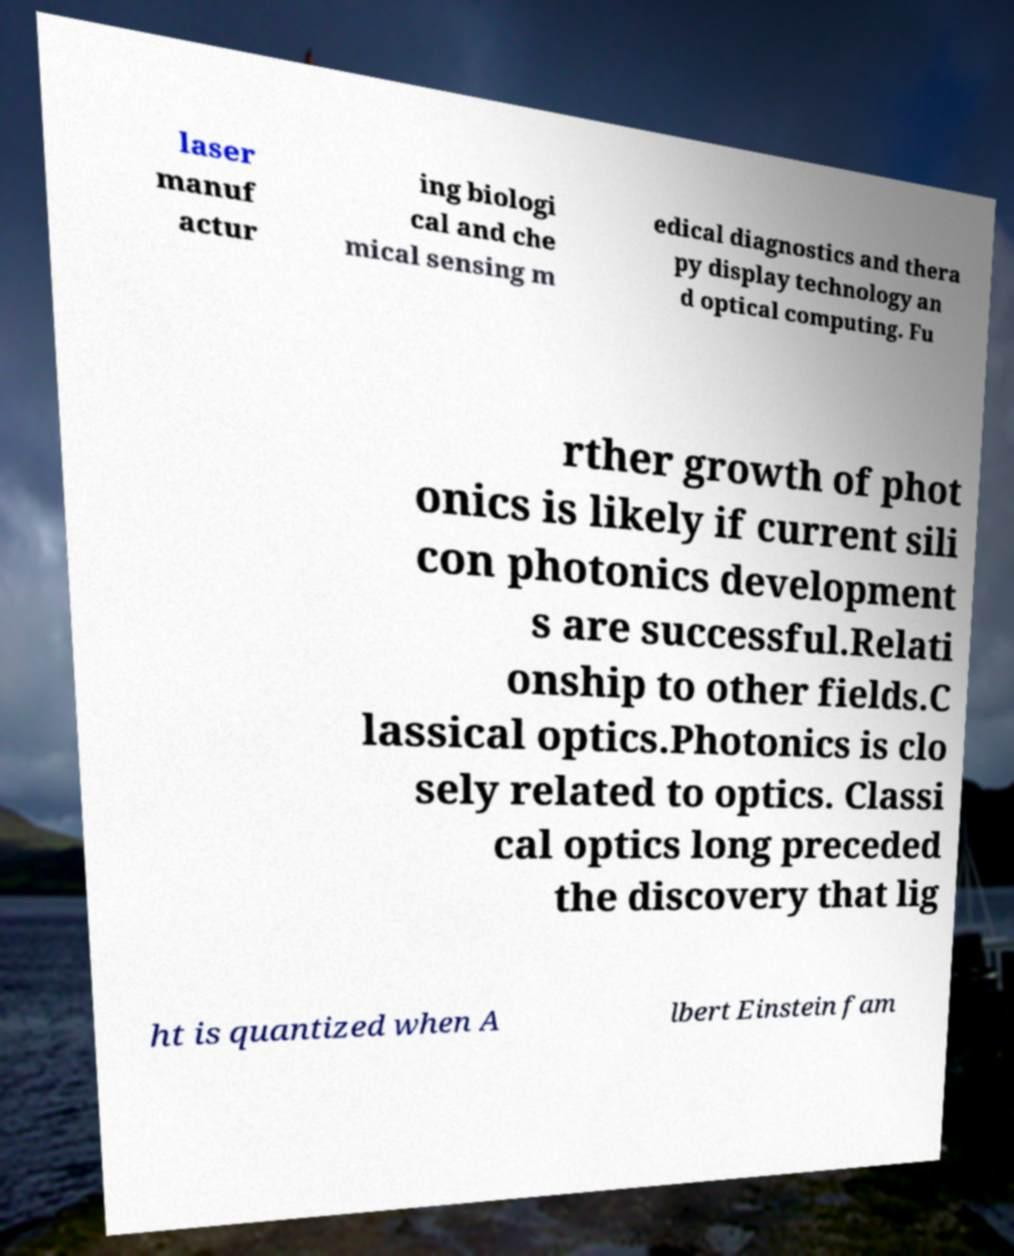What messages or text are displayed in this image? I need them in a readable, typed format. laser manuf actur ing biologi cal and che mical sensing m edical diagnostics and thera py display technology an d optical computing. Fu rther growth of phot onics is likely if current sili con photonics development s are successful.Relati onship to other fields.C lassical optics.Photonics is clo sely related to optics. Classi cal optics long preceded the discovery that lig ht is quantized when A lbert Einstein fam 